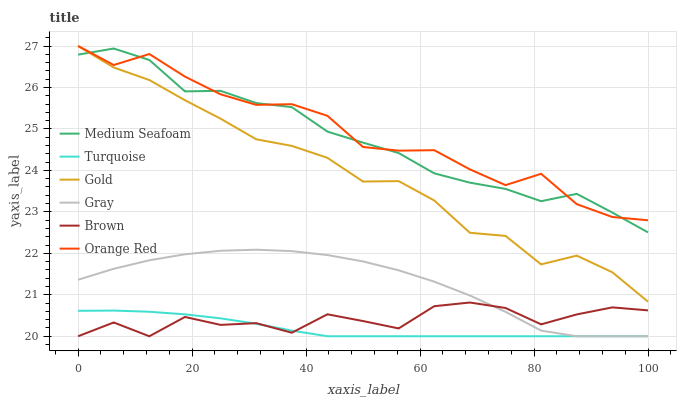Does Turquoise have the minimum area under the curve?
Answer yes or no. Yes. Does Orange Red have the maximum area under the curve?
Answer yes or no. Yes. Does Gold have the minimum area under the curve?
Answer yes or no. No. Does Gold have the maximum area under the curve?
Answer yes or no. No. Is Turquoise the smoothest?
Answer yes or no. Yes. Is Brown the roughest?
Answer yes or no. Yes. Is Gold the smoothest?
Answer yes or no. No. Is Gold the roughest?
Answer yes or no. No. Does Gray have the lowest value?
Answer yes or no. Yes. Does Gold have the lowest value?
Answer yes or no. No. Does Orange Red have the highest value?
Answer yes or no. Yes. Does Turquoise have the highest value?
Answer yes or no. No. Is Turquoise less than Medium Seafoam?
Answer yes or no. Yes. Is Medium Seafoam greater than Brown?
Answer yes or no. Yes. Does Orange Red intersect Gold?
Answer yes or no. Yes. Is Orange Red less than Gold?
Answer yes or no. No. Is Orange Red greater than Gold?
Answer yes or no. No. Does Turquoise intersect Medium Seafoam?
Answer yes or no. No. 